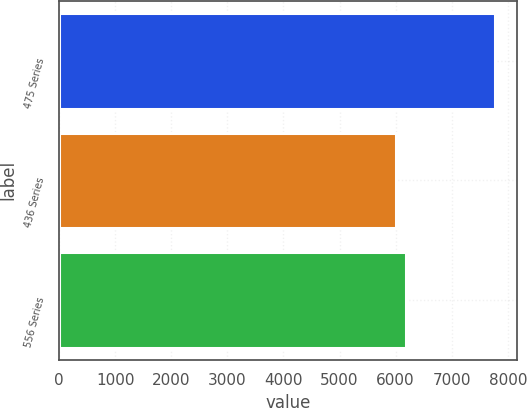<chart> <loc_0><loc_0><loc_500><loc_500><bar_chart><fcel>475 Series<fcel>436 Series<fcel>556 Series<nl><fcel>7780<fcel>6000<fcel>6178<nl></chart> 